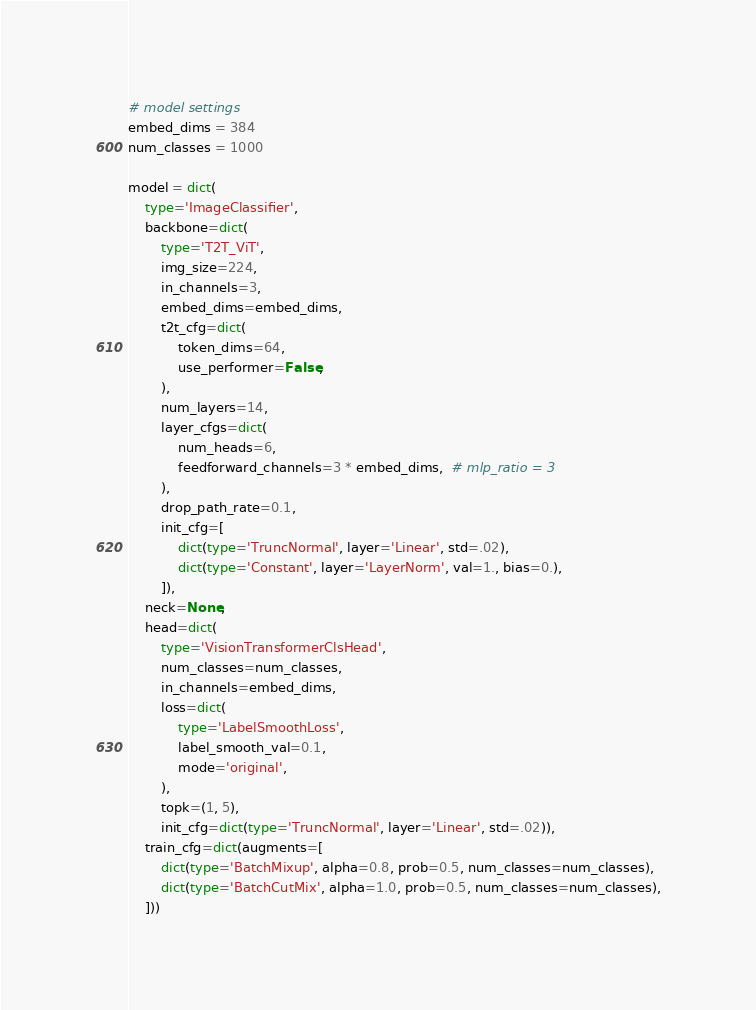Convert code to text. <code><loc_0><loc_0><loc_500><loc_500><_Python_># model settings
embed_dims = 384
num_classes = 1000

model = dict(
    type='ImageClassifier',
    backbone=dict(
        type='T2T_ViT',
        img_size=224,
        in_channels=3,
        embed_dims=embed_dims,
        t2t_cfg=dict(
            token_dims=64,
            use_performer=False,
        ),
        num_layers=14,
        layer_cfgs=dict(
            num_heads=6,
            feedforward_channels=3 * embed_dims,  # mlp_ratio = 3
        ),
        drop_path_rate=0.1,
        init_cfg=[
            dict(type='TruncNormal', layer='Linear', std=.02),
            dict(type='Constant', layer='LayerNorm', val=1., bias=0.),
        ]),
    neck=None,
    head=dict(
        type='VisionTransformerClsHead',
        num_classes=num_classes,
        in_channels=embed_dims,
        loss=dict(
            type='LabelSmoothLoss',
            label_smooth_val=0.1,
            mode='original',
        ),
        topk=(1, 5),
        init_cfg=dict(type='TruncNormal', layer='Linear', std=.02)),
    train_cfg=dict(augments=[
        dict(type='BatchMixup', alpha=0.8, prob=0.5, num_classes=num_classes),
        dict(type='BatchCutMix', alpha=1.0, prob=0.5, num_classes=num_classes),
    ]))
</code> 